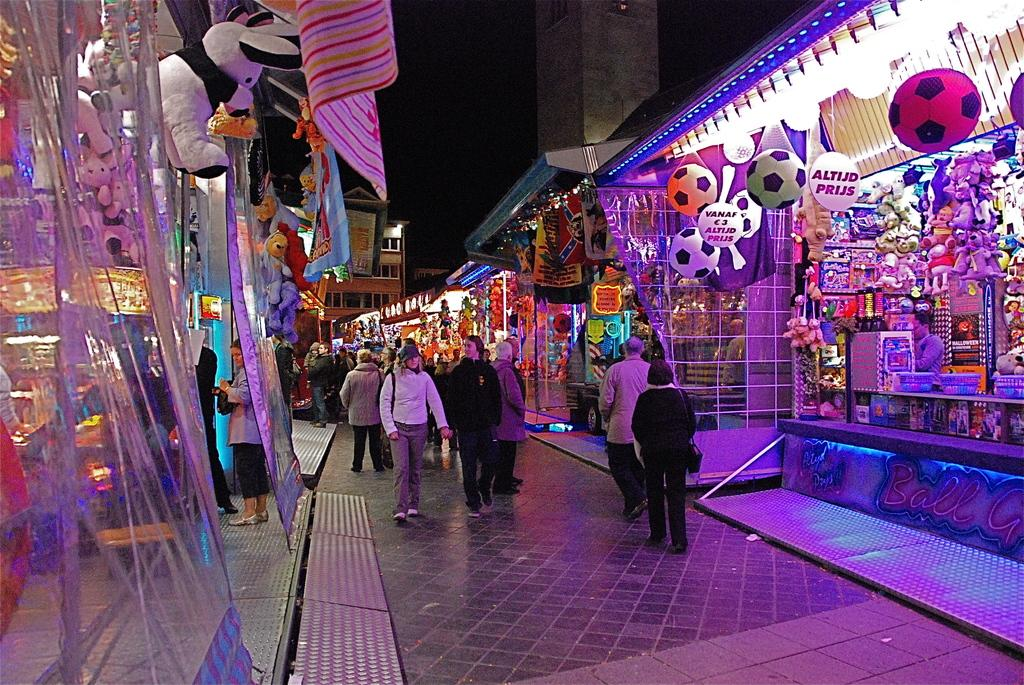What can be seen in the image involving people? There are people standing in the image. What other objects are present in the image? There are toys and dolls in the image. Where are the toys and dolls located? The toys and dolls are in shops. What type of structures can be seen in the image? There are buildings in the image. Can you describe a specific architectural feature in the image? There is a pillar in the image. What type of record can be seen in the image? There is no record present in the image. Can you describe the cow that is grazing in the image? There is no cow present in the image. 